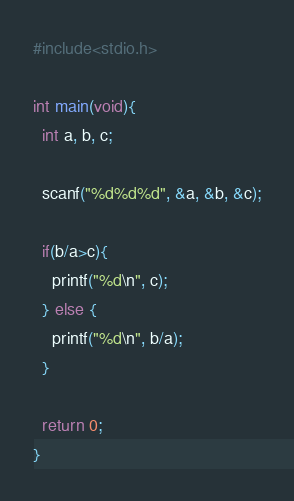Convert code to text. <code><loc_0><loc_0><loc_500><loc_500><_C_>#include<stdio.h>

int main(void){
  int a, b, c;
  
  scanf("%d%d%d", &a, &b, &c);
  
  if(b/a>c){
    printf("%d\n", c);
  } else {
    printf("%d\n", b/a);
  }
  
  return 0;
}</code> 